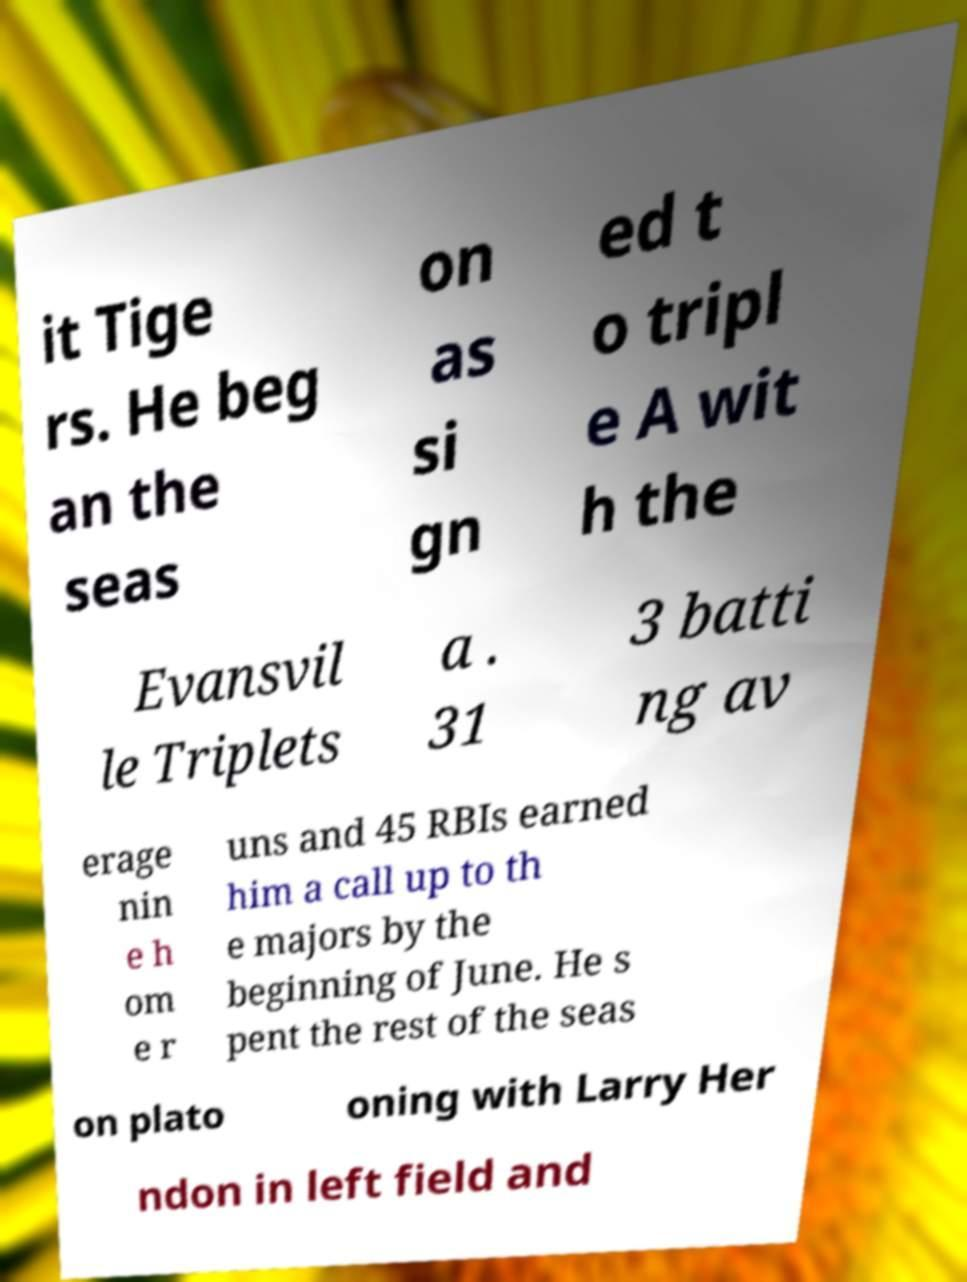There's text embedded in this image that I need extracted. Can you transcribe it verbatim? it Tige rs. He beg an the seas on as si gn ed t o tripl e A wit h the Evansvil le Triplets a . 31 3 batti ng av erage nin e h om e r uns and 45 RBIs earned him a call up to th e majors by the beginning of June. He s pent the rest of the seas on plato oning with Larry Her ndon in left field and 